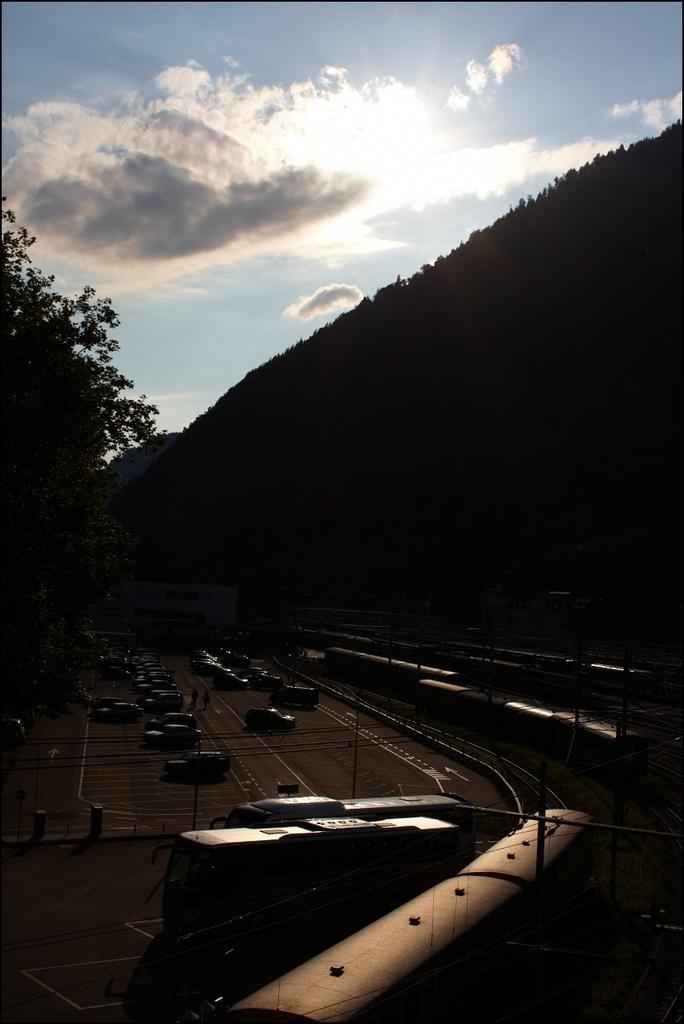What types of vehicles can be seen on the path in the image? There are vehicles on a path in the image. What other mode of transportation is present in the image? There is a train on a railway track in the image. What natural element is visible on the left side of the image? A tree is visible on the left side of the image. How would you describe the sky in the image? The sky is blue and cloudy in the image. What type of pancake is being served to the worm in the image? There is no pancake or worm present in the image. 